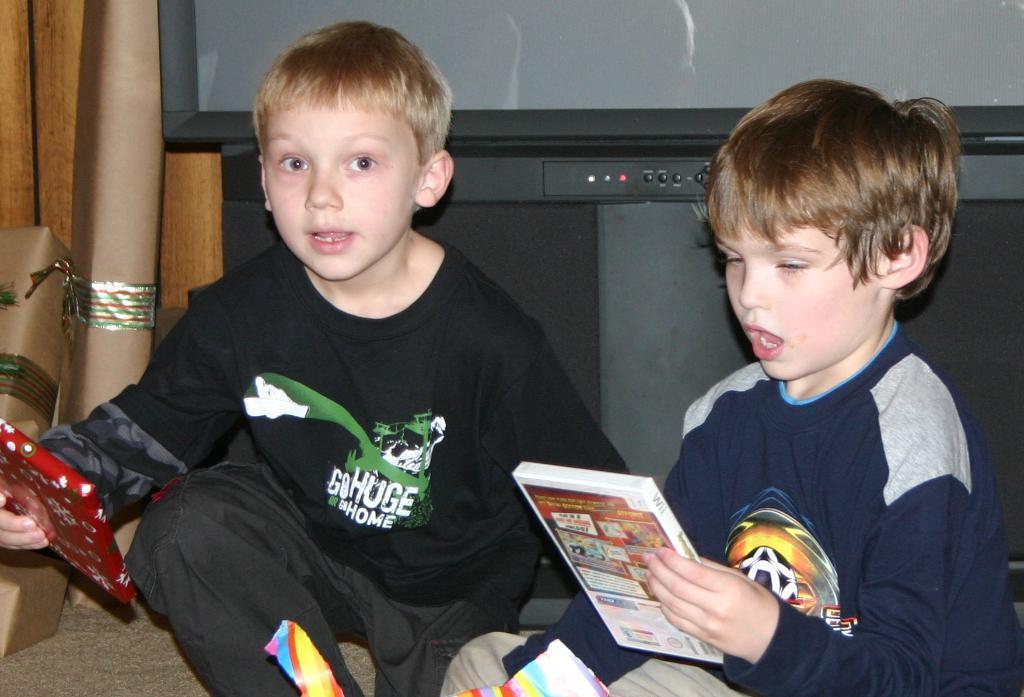Can you describe this image briefly? In this image I can see two children and I can see both of them are wearing t shirts. I can also see both of them are holding few things. In the background I can see few brown colour things and a television. 